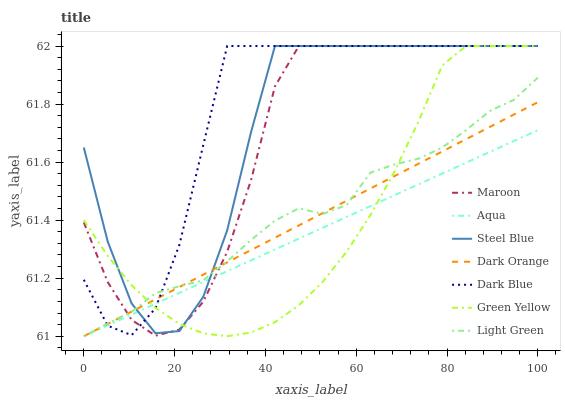Does Aqua have the minimum area under the curve?
Answer yes or no. Yes. Does Dark Blue have the maximum area under the curve?
Answer yes or no. Yes. Does Steel Blue have the minimum area under the curve?
Answer yes or no. No. Does Steel Blue have the maximum area under the curve?
Answer yes or no. No. Is Dark Orange the smoothest?
Answer yes or no. Yes. Is Steel Blue the roughest?
Answer yes or no. Yes. Is Aqua the smoothest?
Answer yes or no. No. Is Aqua the roughest?
Answer yes or no. No. Does Dark Orange have the lowest value?
Answer yes or no. Yes. Does Steel Blue have the lowest value?
Answer yes or no. No. Does Green Yellow have the highest value?
Answer yes or no. Yes. Does Aqua have the highest value?
Answer yes or no. No. Does Dark Blue intersect Aqua?
Answer yes or no. Yes. Is Dark Blue less than Aqua?
Answer yes or no. No. Is Dark Blue greater than Aqua?
Answer yes or no. No. 